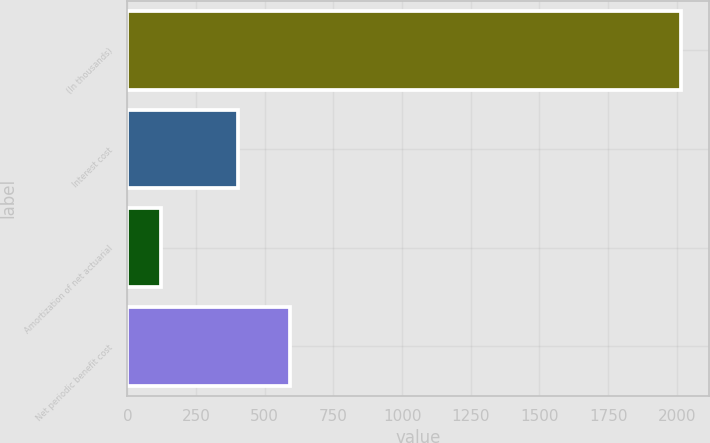Convert chart. <chart><loc_0><loc_0><loc_500><loc_500><bar_chart><fcel>(In thousands)<fcel>Interest cost<fcel>Amortization of net actuarial<fcel>Net periodic benefit cost<nl><fcel>2015<fcel>403<fcel>123<fcel>592.2<nl></chart> 